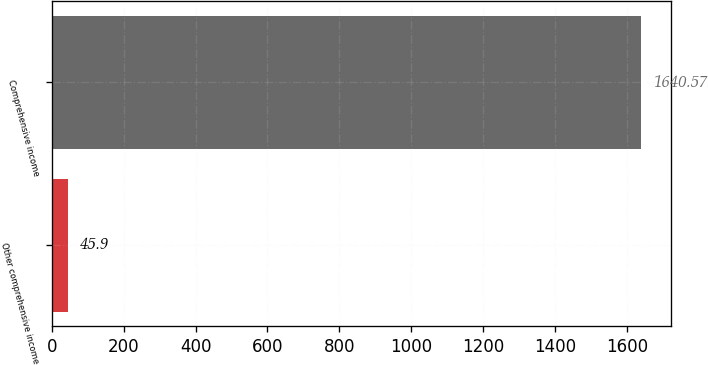Convert chart. <chart><loc_0><loc_0><loc_500><loc_500><bar_chart><fcel>Other comprehensive income<fcel>Comprehensive income<nl><fcel>45.9<fcel>1640.57<nl></chart> 